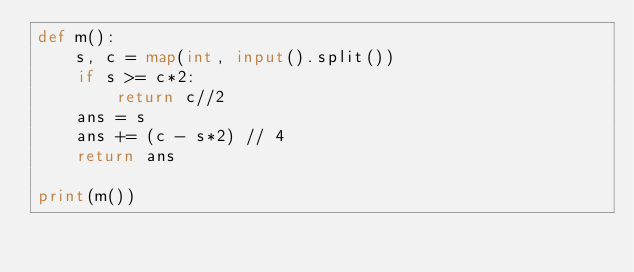<code> <loc_0><loc_0><loc_500><loc_500><_Python_>def m():
    s, c = map(int, input().split())
    if s >= c*2:
        return c//2
    ans = s
    ans += (c - s*2) // 4
    return ans

print(m())</code> 